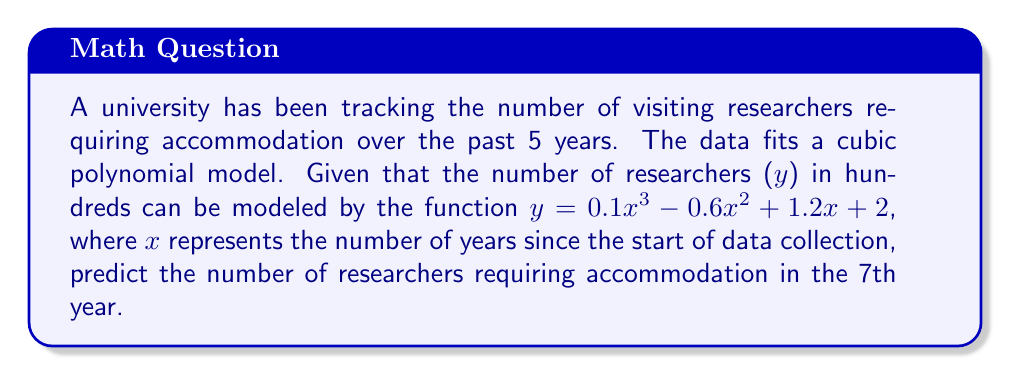Solve this math problem. To solve this problem, we need to follow these steps:

1) The given polynomial function is:
   $y = 0.1x^3 - 0.6x^2 + 1.2x + 2$

2) We need to find y when x = 7 (7th year):
   $y = 0.1(7)^3 - 0.6(7)^2 + 1.2(7) + 2$

3) Let's calculate each term:
   - $0.1(7)^3 = 0.1 * 343 = 34.3$
   - $-0.6(7)^2 = -0.6 * 49 = -29.4$
   - $1.2(7) = 8.4$
   - The constant term is 2

4) Now, let's sum up all these terms:
   $y = 34.3 - 29.4 + 8.4 + 2 = 15.3$

5) Remember that y represents the number of researchers in hundreds. So we need to multiply by 100:
   $15.3 * 100 = 1530$

Therefore, in the 7th year, the model predicts that 1530 researchers will require accommodation.
Answer: 1530 researchers 